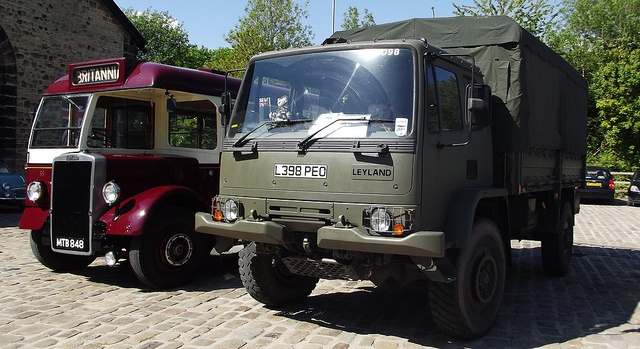Describe the objects in this image and their specific colors. I can see truck in black, gray, and darkgray tones, bus in black, maroon, gray, and darkgreen tones, car in black, navy, gray, and darkblue tones, car in black, gray, darkgray, and maroon tones, and car in black, gray, lightgray, and darkgray tones in this image. 